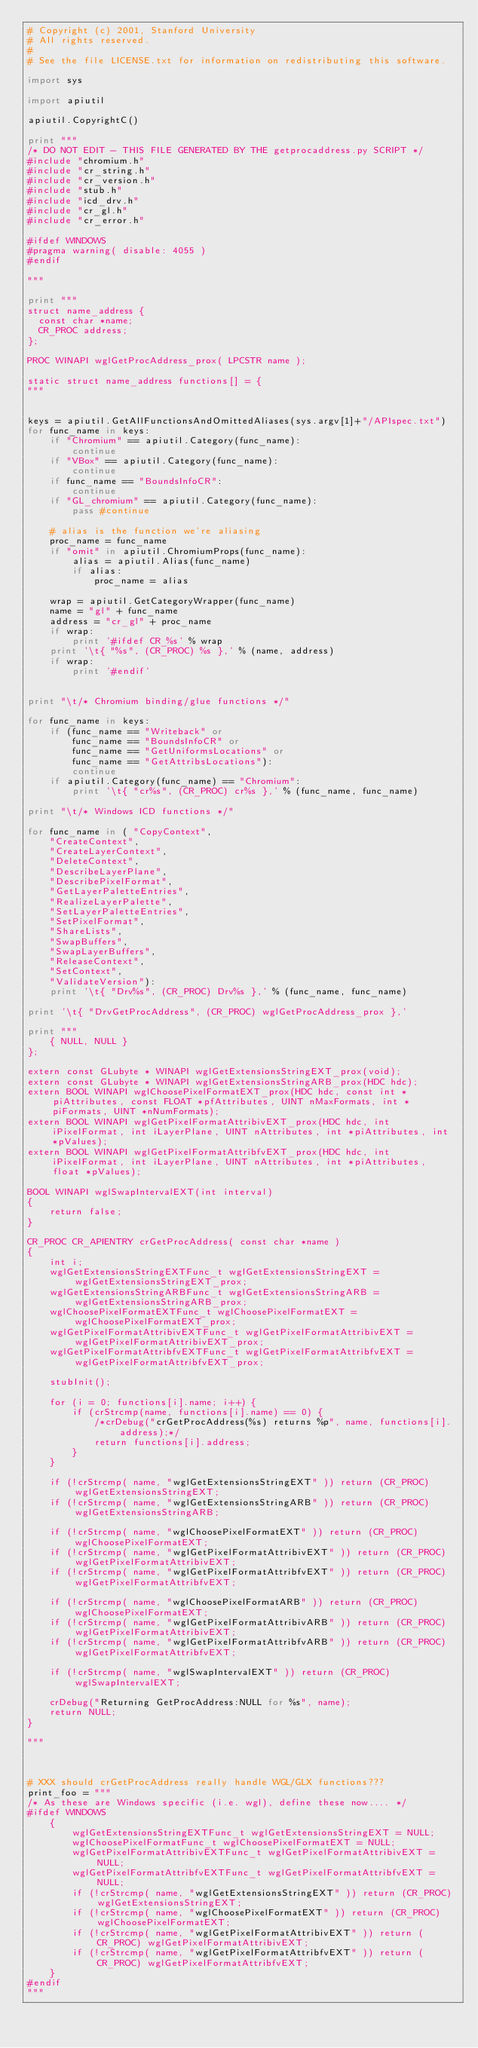<code> <loc_0><loc_0><loc_500><loc_500><_Python_># Copyright (c) 2001, Stanford University
# All rights reserved.
#
# See the file LICENSE.txt for information on redistributing this software.

import sys

import apiutil

apiutil.CopyrightC()

print """
/* DO NOT EDIT - THIS FILE GENERATED BY THE getprocaddress.py SCRIPT */
#include "chromium.h"
#include "cr_string.h"
#include "cr_version.h"
#include "stub.h"
#include "icd_drv.h"
#include "cr_gl.h"
#include "cr_error.h"

#ifdef WINDOWS
#pragma warning( disable: 4055 )
#endif

"""

print """
struct name_address {
  const char *name;
  CR_PROC address;
};

PROC WINAPI wglGetProcAddress_prox( LPCSTR name );

static struct name_address functions[] = {
"""


keys = apiutil.GetAllFunctionsAndOmittedAliases(sys.argv[1]+"/APIspec.txt")
for func_name in keys:
    if "Chromium" == apiutil.Category(func_name):
        continue
    if "VBox" == apiutil.Category(func_name):
        continue
    if func_name == "BoundsInfoCR":
        continue
    if "GL_chromium" == apiutil.Category(func_name):
        pass #continue

    # alias is the function we're aliasing
    proc_name = func_name
    if "omit" in apiutil.ChromiumProps(func_name):
        alias = apiutil.Alias(func_name)
        if alias:
            proc_name = alias

    wrap = apiutil.GetCategoryWrapper(func_name)
    name = "gl" + func_name
    address = "cr_gl" + proc_name
    if wrap:
        print '#ifdef CR_%s' % wrap
    print '\t{ "%s", (CR_PROC) %s },' % (name, address)
    if wrap:
        print '#endif'


print "\t/* Chromium binding/glue functions */"

for func_name in keys:
    if (func_name == "Writeback" or
        func_name == "BoundsInfoCR" or
        func_name == "GetUniformsLocations" or
        func_name == "GetAttribsLocations"):
        continue
    if apiutil.Category(func_name) == "Chromium":
        print '\t{ "cr%s", (CR_PROC) cr%s },' % (func_name, func_name)

print "\t/* Windows ICD functions */"

for func_name in ( "CopyContext",
    "CreateContext",
    "CreateLayerContext",
    "DeleteContext",
    "DescribeLayerPlane",
    "DescribePixelFormat",
    "GetLayerPaletteEntries",
    "RealizeLayerPalette",
    "SetLayerPaletteEntries",
    "SetPixelFormat",
    "ShareLists",
    "SwapBuffers",
    "SwapLayerBuffers",
    "ReleaseContext",
    "SetContext",
    "ValidateVersion"):
    print '\t{ "Drv%s", (CR_PROC) Drv%s },' % (func_name, func_name)

print '\t{ "DrvGetProcAddress", (CR_PROC) wglGetProcAddress_prox },'

print """
    { NULL, NULL }
};

extern const GLubyte * WINAPI wglGetExtensionsStringEXT_prox(void);
extern const GLubyte * WINAPI wglGetExtensionsStringARB_prox(HDC hdc);
extern BOOL WINAPI wglChoosePixelFormatEXT_prox(HDC hdc, const int *piAttributes, const FLOAT *pfAttributes, UINT nMaxFormats, int *piFormats, UINT *nNumFormats);
extern BOOL WINAPI wglGetPixelFormatAttribivEXT_prox(HDC hdc, int iPixelFormat, int iLayerPlane, UINT nAttributes, int *piAttributes, int *pValues);
extern BOOL WINAPI wglGetPixelFormatAttribfvEXT_prox(HDC hdc, int iPixelFormat, int iLayerPlane, UINT nAttributes, int *piAttributes, float *pValues);

BOOL WINAPI wglSwapIntervalEXT(int interval)
{
    return false;
}

CR_PROC CR_APIENTRY crGetProcAddress( const char *name )
{
    int i;
    wglGetExtensionsStringEXTFunc_t wglGetExtensionsStringEXT = wglGetExtensionsStringEXT_prox;
    wglGetExtensionsStringARBFunc_t wglGetExtensionsStringARB = wglGetExtensionsStringARB_prox;
    wglChoosePixelFormatEXTFunc_t wglChoosePixelFormatEXT = wglChoosePixelFormatEXT_prox;
    wglGetPixelFormatAttribivEXTFunc_t wglGetPixelFormatAttribivEXT = wglGetPixelFormatAttribivEXT_prox;
    wglGetPixelFormatAttribfvEXTFunc_t wglGetPixelFormatAttribfvEXT = wglGetPixelFormatAttribfvEXT_prox;

    stubInit();

    for (i = 0; functions[i].name; i++) {
        if (crStrcmp(name, functions[i].name) == 0) {
            /*crDebug("crGetProcAddress(%s) returns %p", name, functions[i].address);*/
            return functions[i].address;
        }
    }

    if (!crStrcmp( name, "wglGetExtensionsStringEXT" )) return (CR_PROC) wglGetExtensionsStringEXT;
    if (!crStrcmp( name, "wglGetExtensionsStringARB" )) return (CR_PROC) wglGetExtensionsStringARB;

    if (!crStrcmp( name, "wglChoosePixelFormatEXT" )) return (CR_PROC) wglChoosePixelFormatEXT;
    if (!crStrcmp( name, "wglGetPixelFormatAttribivEXT" )) return (CR_PROC) wglGetPixelFormatAttribivEXT;
    if (!crStrcmp( name, "wglGetPixelFormatAttribfvEXT" )) return (CR_PROC) wglGetPixelFormatAttribfvEXT;

    if (!crStrcmp( name, "wglChoosePixelFormatARB" )) return (CR_PROC) wglChoosePixelFormatEXT;
    if (!crStrcmp( name, "wglGetPixelFormatAttribivARB" )) return (CR_PROC) wglGetPixelFormatAttribivEXT;
    if (!crStrcmp( name, "wglGetPixelFormatAttribfvARB" )) return (CR_PROC) wglGetPixelFormatAttribfvEXT;

    if (!crStrcmp( name, "wglSwapIntervalEXT" )) return (CR_PROC) wglSwapIntervalEXT;
    
    crDebug("Returning GetProcAddress:NULL for %s", name);
    return NULL;
}

"""



# XXX should crGetProcAddress really handle WGL/GLX functions???
print_foo = """
/* As these are Windows specific (i.e. wgl), define these now.... */
#ifdef WINDOWS
    {
        wglGetExtensionsStringEXTFunc_t wglGetExtensionsStringEXT = NULL;
        wglChoosePixelFormatFunc_t wglChoosePixelFormatEXT = NULL;
        wglGetPixelFormatAttribivEXTFunc_t wglGetPixelFormatAttribivEXT = NULL;
        wglGetPixelFormatAttribfvEXTFunc_t wglGetPixelFormatAttribfvEXT = NULL;
        if (!crStrcmp( name, "wglGetExtensionsStringEXT" )) return (CR_PROC) wglGetExtensionsStringEXT;
        if (!crStrcmp( name, "wglChoosePixelFormatEXT" )) return (CR_PROC) wglChoosePixelFormatEXT;
        if (!crStrcmp( name, "wglGetPixelFormatAttribivEXT" )) return (CR_PROC) wglGetPixelFormatAttribivEXT;
        if (!crStrcmp( name, "wglGetPixelFormatAttribfvEXT" )) return (CR_PROC) wglGetPixelFormatAttribfvEXT;
    }
#endif
"""
</code> 